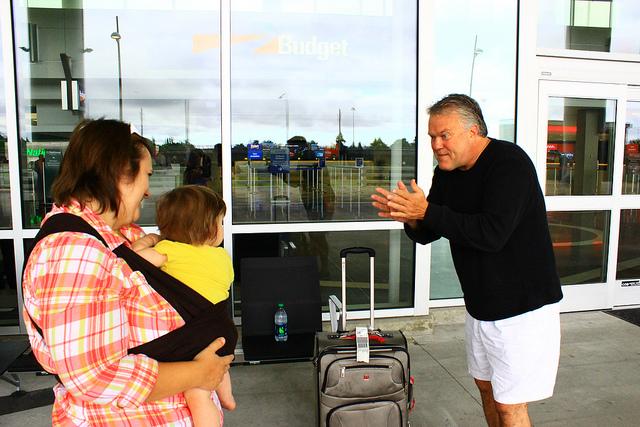Is the man catching an object or attracting someone's attention?
Answer briefly. Attracting someone's attention. Who is the man looking at?
Quick response, please. Child. Is the scene reflected?
Be succinct. Yes. 